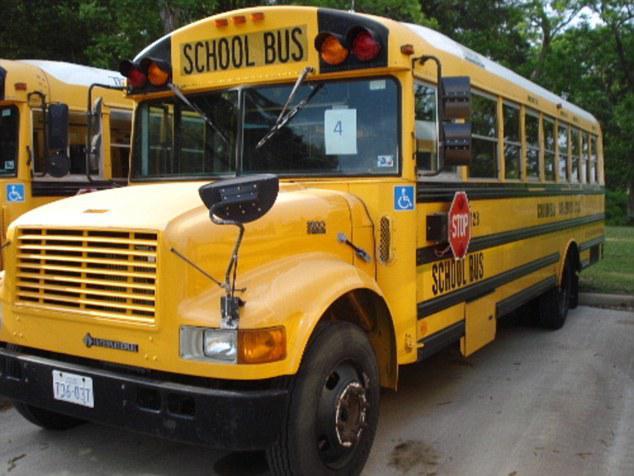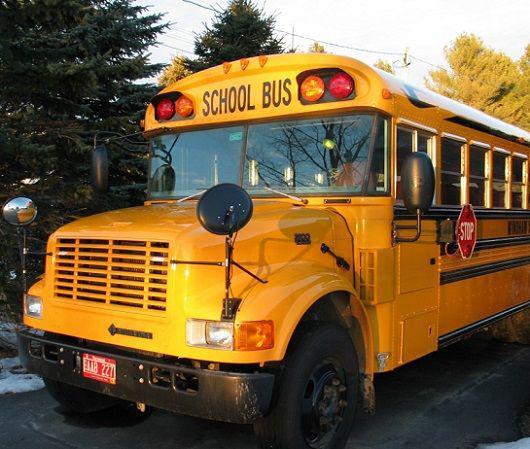The first image is the image on the left, the second image is the image on the right. Examine the images to the left and right. Is the description "The right image shows a leftward-angled non-flat bus, and the left image shows the front of a parked non-flat bus that has only one hood and grille and has a license plate on its front bumper." accurate? Answer yes or no. Yes. The first image is the image on the left, the second image is the image on the right. Assess this claim about the two images: "In one of the images, the bus passenger door is open.". Correct or not? Answer yes or no. No. 